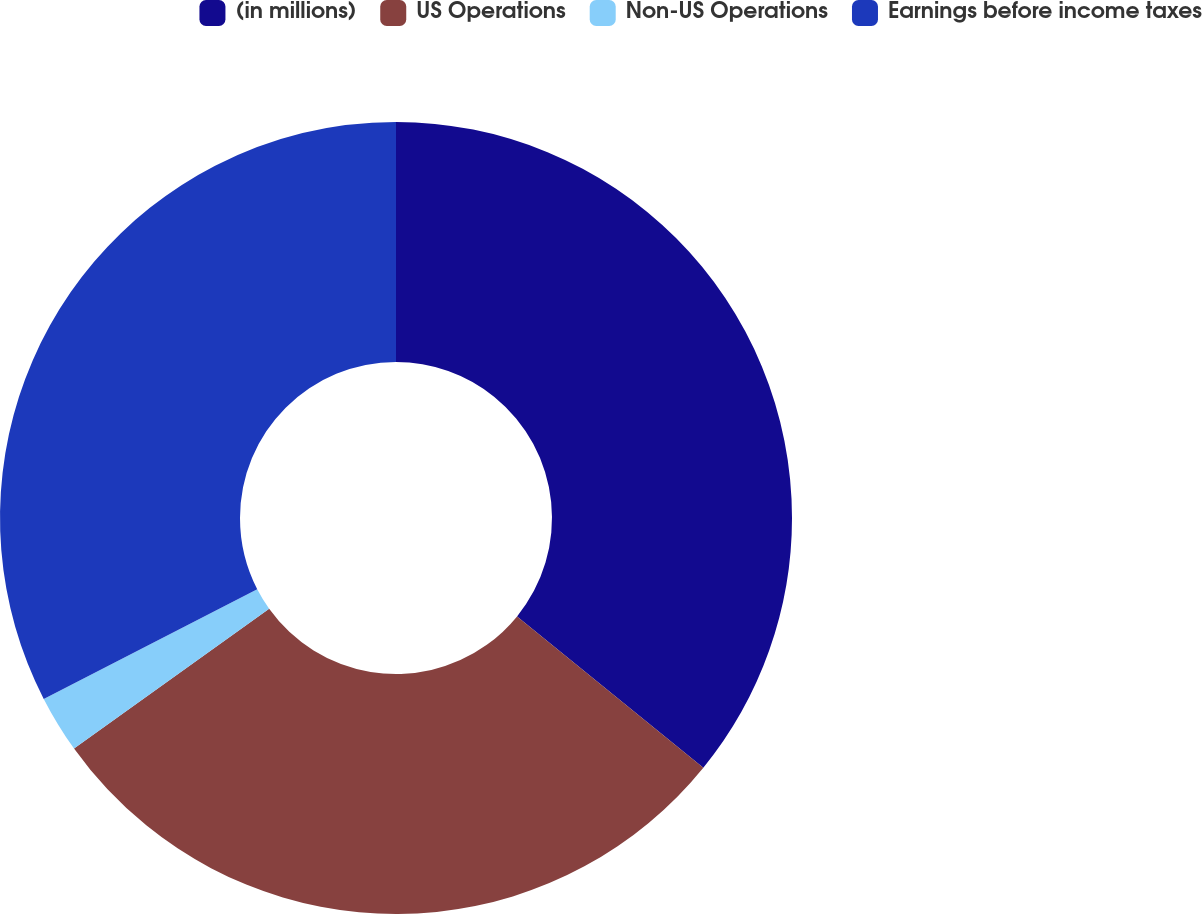Convert chart. <chart><loc_0><loc_0><loc_500><loc_500><pie_chart><fcel>(in millions)<fcel>US Operations<fcel>Non-US Operations<fcel>Earnings before income taxes<nl><fcel>35.86%<fcel>29.25%<fcel>2.34%<fcel>32.55%<nl></chart> 